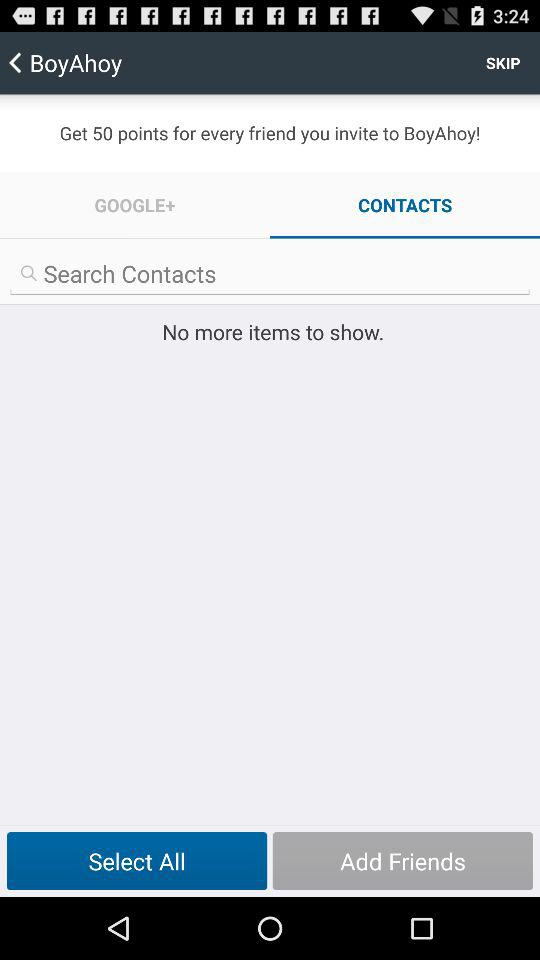How many points do we get for inviting each friend to "BoyAhoy"? You get 50 points for inviting each friend to "BoyAhoy". 